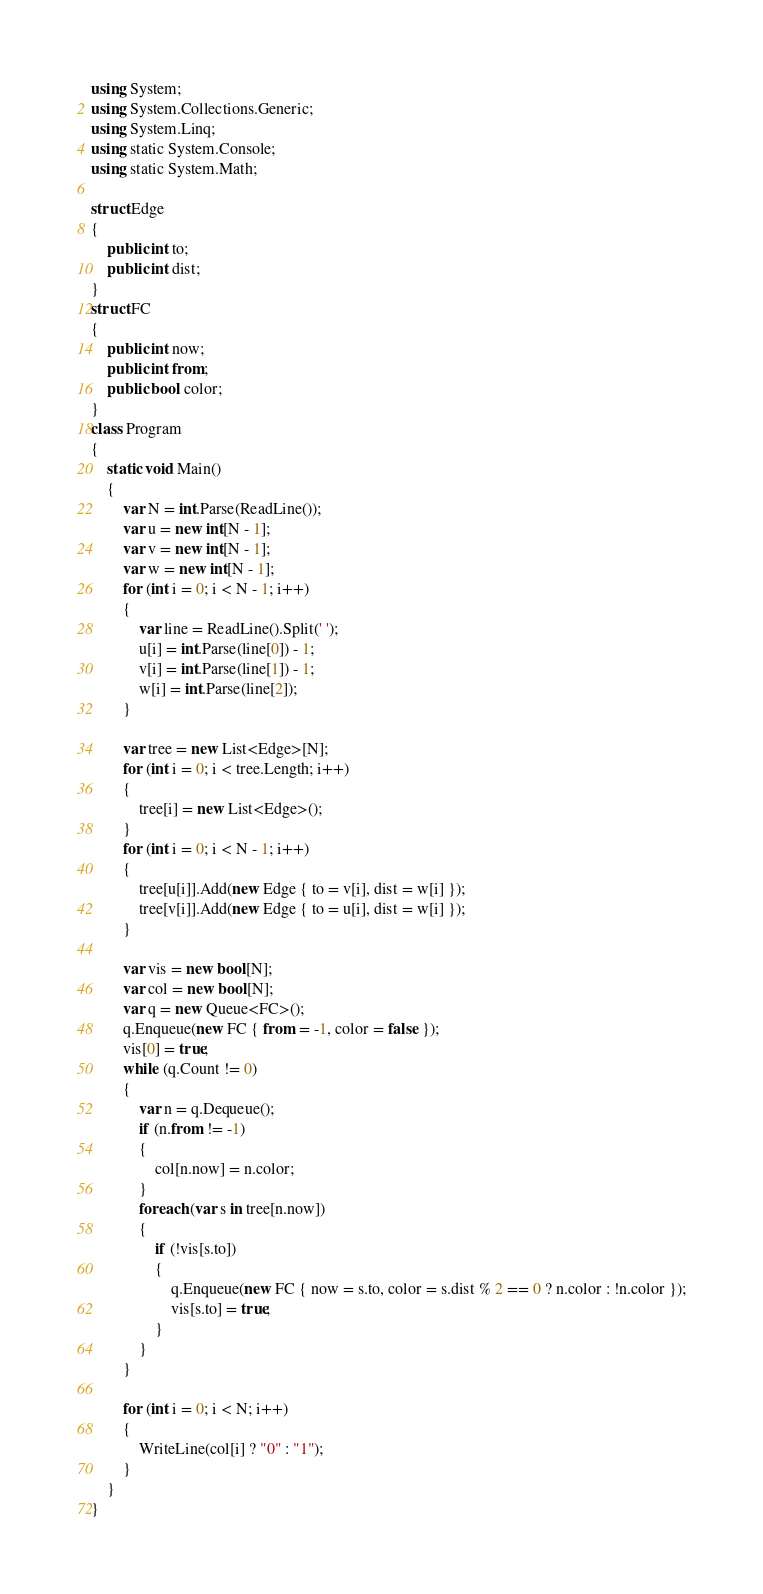<code> <loc_0><loc_0><loc_500><loc_500><_C#_>using System;
using System.Collections.Generic;
using System.Linq;
using static System.Console;
using static System.Math;

struct Edge
{
    public int to;
    public int dist;
}
struct FC
{
    public int now;
    public int from;
    public bool color;
}
class Program
{
    static void Main()
    {
        var N = int.Parse(ReadLine());
        var u = new int[N - 1];
        var v = new int[N - 1];
        var w = new int[N - 1];
        for (int i = 0; i < N - 1; i++)
        {
            var line = ReadLine().Split(' ');
            u[i] = int.Parse(line[0]) - 1;
            v[i] = int.Parse(line[1]) - 1;
            w[i] = int.Parse(line[2]);
        }

        var tree = new List<Edge>[N];
        for (int i = 0; i < tree.Length; i++)
        {
            tree[i] = new List<Edge>();
        }
        for (int i = 0; i < N - 1; i++)
        {
            tree[u[i]].Add(new Edge { to = v[i], dist = w[i] });
            tree[v[i]].Add(new Edge { to = u[i], dist = w[i] });
        }

        var vis = new bool[N];
        var col = new bool[N];
        var q = new Queue<FC>();
        q.Enqueue(new FC { from = -1, color = false });
        vis[0] = true;
        while (q.Count != 0)
        {
            var n = q.Dequeue();
            if (n.from != -1)
            {
                col[n.now] = n.color;
            }
            foreach (var s in tree[n.now])
            {
                if (!vis[s.to])
                {
                    q.Enqueue(new FC { now = s.to, color = s.dist % 2 == 0 ? n.color : !n.color });
                    vis[s.to] = true;
                }
            }
        }

        for (int i = 0; i < N; i++)
        {
            WriteLine(col[i] ? "0" : "1");
        }
    }
}
</code> 